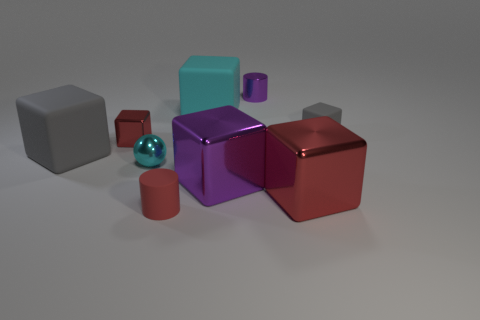Is there anything else that has the same color as the tiny matte block?
Provide a succinct answer. Yes. Do the tiny shiny cylinder and the big metal thing that is to the left of the small purple shiny object have the same color?
Your answer should be compact. Yes. There is a big red shiny object; is it the same shape as the large metal thing that is to the left of the big red metallic block?
Your response must be concise. Yes. There is a rubber thing that is the same color as the small matte block; what is its shape?
Your answer should be compact. Cube. Is the number of big gray rubber things that are to the right of the small purple metal object less than the number of tiny cyan balls?
Make the answer very short. Yes. Do the small gray matte thing and the red rubber thing have the same shape?
Your response must be concise. No. There is a cyan thing that is the same material as the small red cylinder; what is its size?
Ensure brevity in your answer.  Large. Are there fewer big matte objects than big red shiny blocks?
Your answer should be compact. No. How many tiny objects are cyan rubber blocks or red rubber cylinders?
Give a very brief answer. 1. What number of rubber blocks are to the left of the tiny gray rubber cube and in front of the big cyan matte object?
Your response must be concise. 1. 